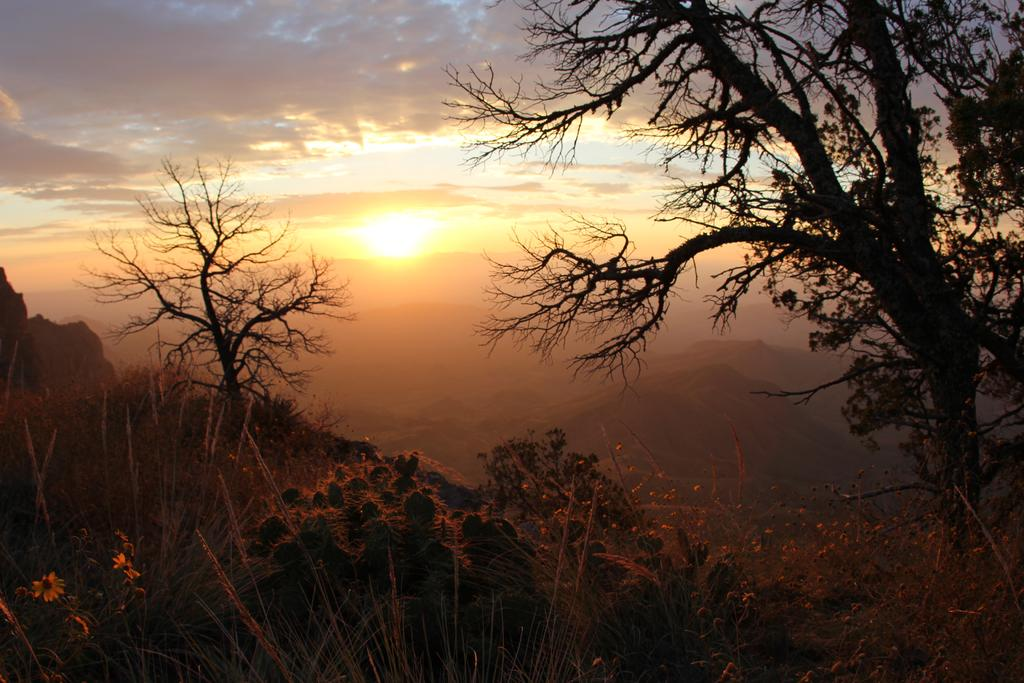What type of vegetation can be seen in the image? There are trees and plants in the image. What is the primary celestial body visible in the sky in the image? The sun is visible in the sky in the middle of the image. What type of market can be seen in the image? There is no market present in the image; it features trees, plants, and the sun in the sky. 